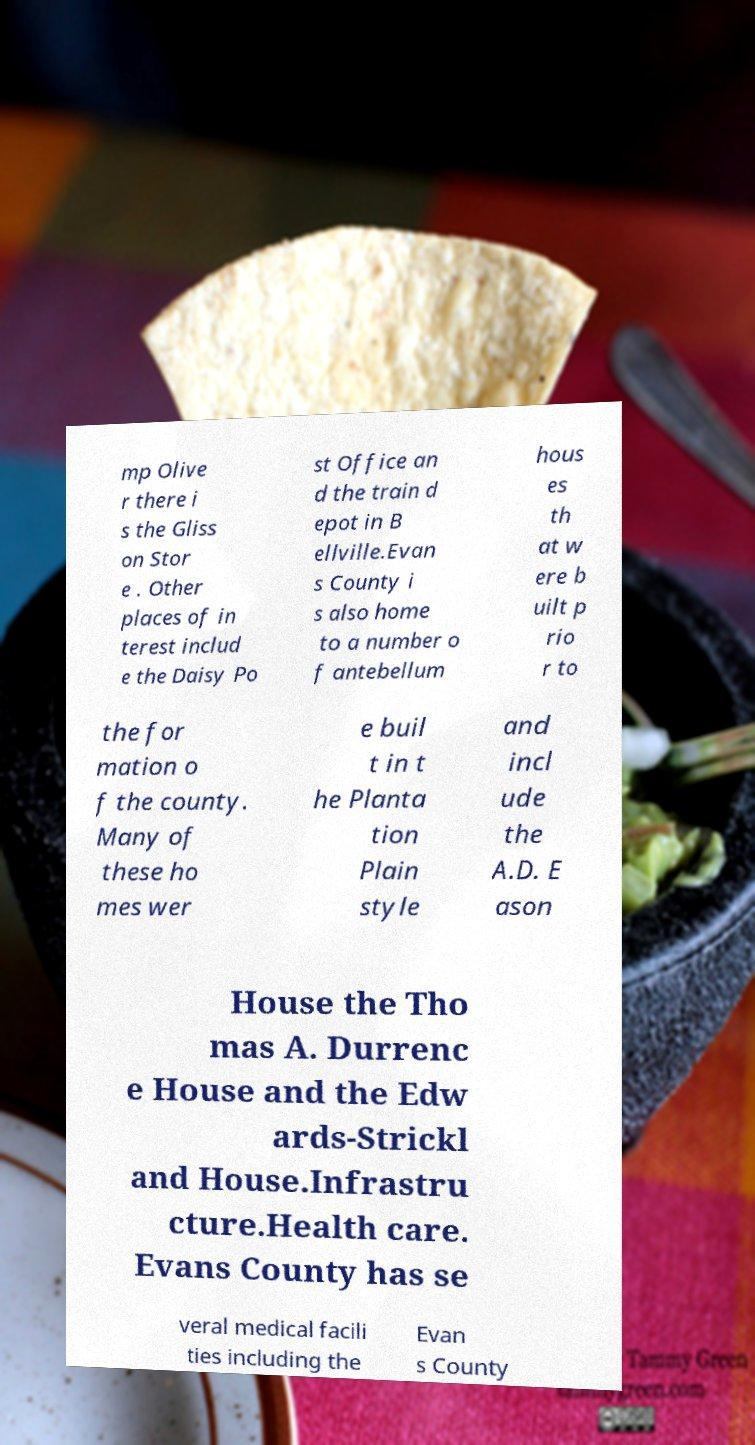What messages or text are displayed in this image? I need them in a readable, typed format. mp Olive r there i s the Gliss on Stor e . Other places of in terest includ e the Daisy Po st Office an d the train d epot in B ellville.Evan s County i s also home to a number o f antebellum hous es th at w ere b uilt p rio r to the for mation o f the county. Many of these ho mes wer e buil t in t he Planta tion Plain style and incl ude the A.D. E ason House the Tho mas A. Durrenc e House and the Edw ards-Strickl and House.Infrastru cture.Health care. Evans County has se veral medical facili ties including the Evan s County 